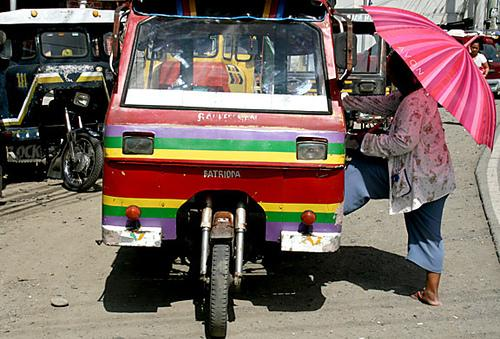What does the front of the automobile shown in this image most resemble? Please explain your reasoning. rainbow. (a) rainbow. the stripes on the front of the auto are similar or the same as the colors you see in a rainbow. 